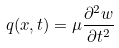<formula> <loc_0><loc_0><loc_500><loc_500>q ( x , t ) = \mu { \frac { \partial ^ { 2 } w } { \partial t ^ { 2 } } }</formula> 